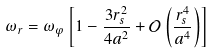Convert formula to latex. <formula><loc_0><loc_0><loc_500><loc_500>\omega _ { r } = \omega _ { \varphi } \left [ 1 - { \frac { 3 r _ { s } ^ { 2 } } { 4 a ^ { 2 } } } + { \mathcal { O } } \left ( { \frac { r _ { s } ^ { 4 } } { a ^ { 4 } } } \right ) \right ]</formula> 